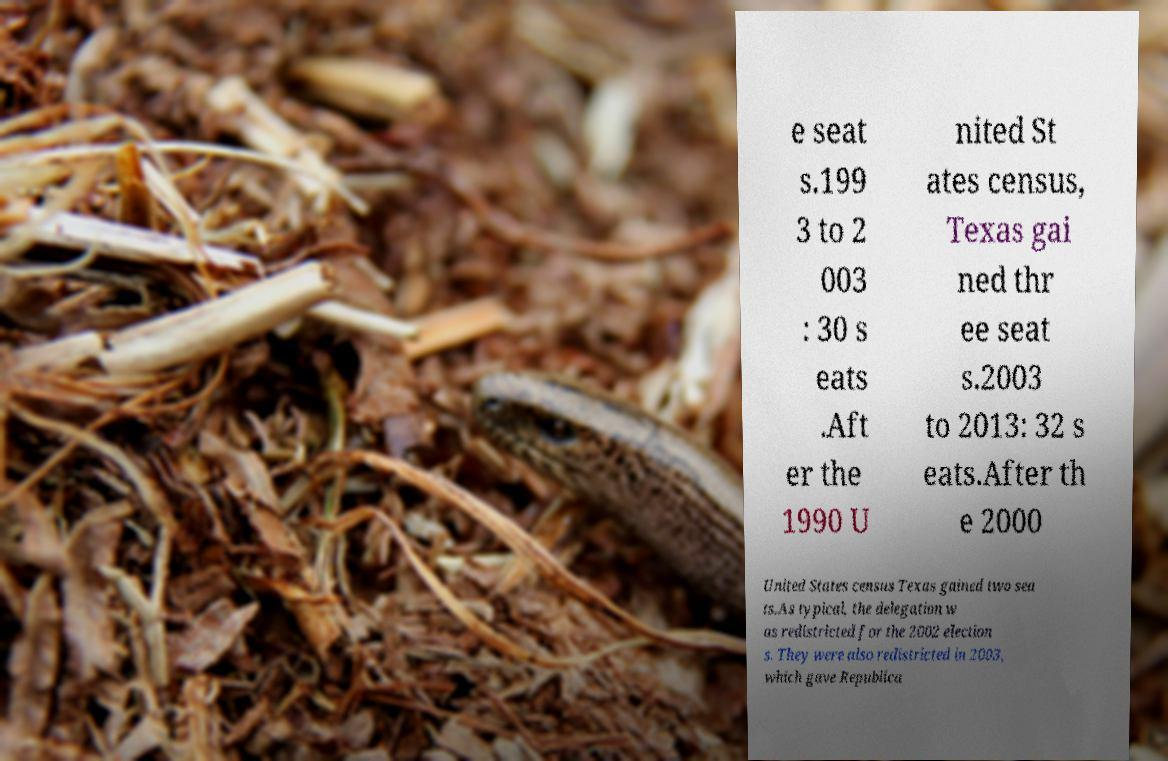Can you read and provide the text displayed in the image?This photo seems to have some interesting text. Can you extract and type it out for me? e seat s.199 3 to 2 003 : 30 s eats .Aft er the 1990 U nited St ates census, Texas gai ned thr ee seat s.2003 to 2013: 32 s eats.After th e 2000 United States census Texas gained two sea ts.As typical, the delegation w as redistricted for the 2002 election s. They were also redistricted in 2003, which gave Republica 